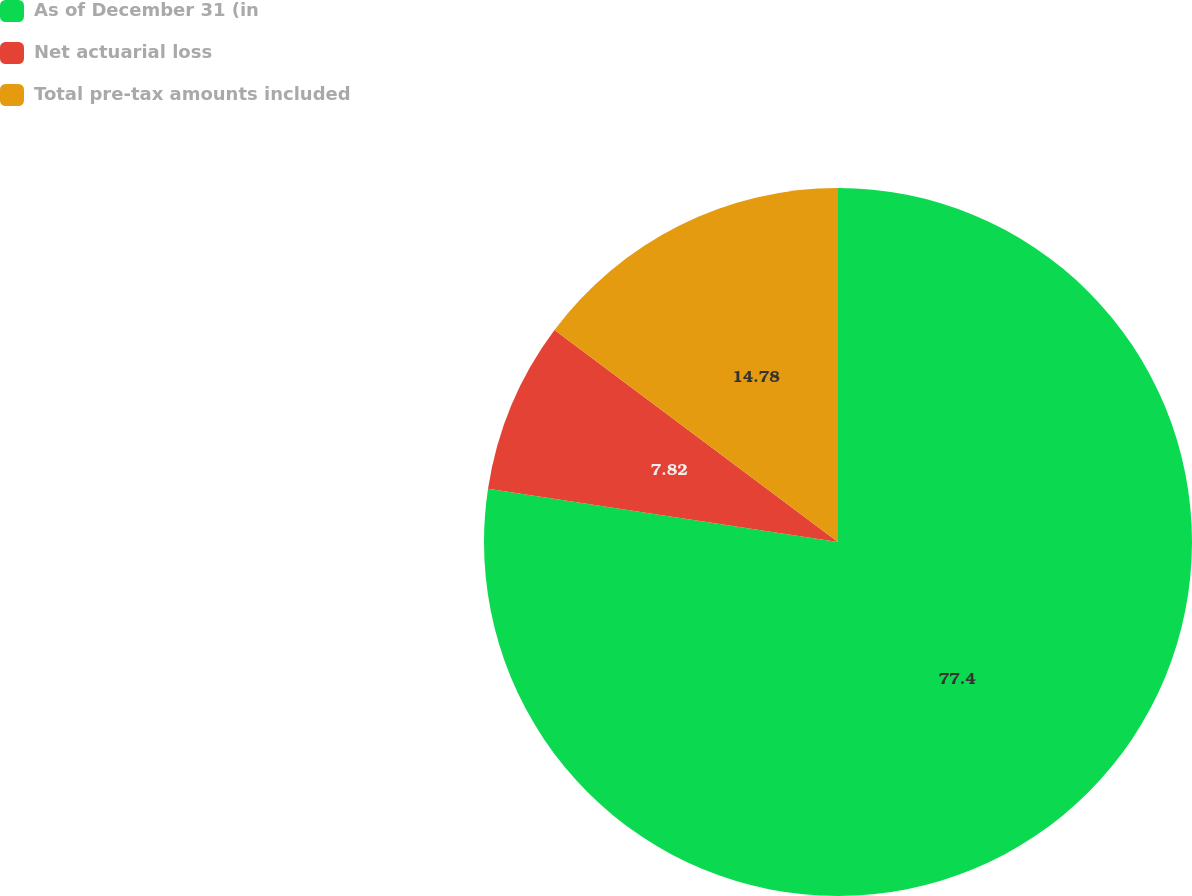Convert chart. <chart><loc_0><loc_0><loc_500><loc_500><pie_chart><fcel>As of December 31 (in<fcel>Net actuarial loss<fcel>Total pre-tax amounts included<nl><fcel>77.4%<fcel>7.82%<fcel>14.78%<nl></chart> 